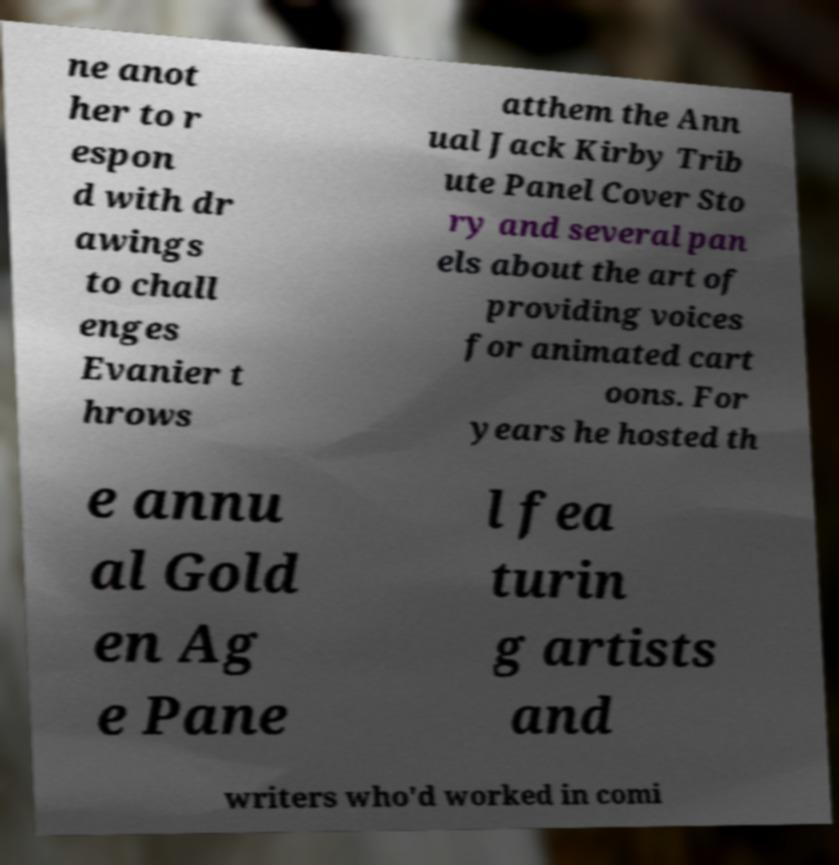Please identify and transcribe the text found in this image. ne anot her to r espon d with dr awings to chall enges Evanier t hrows atthem the Ann ual Jack Kirby Trib ute Panel Cover Sto ry and several pan els about the art of providing voices for animated cart oons. For years he hosted th e annu al Gold en Ag e Pane l fea turin g artists and writers who'd worked in comi 